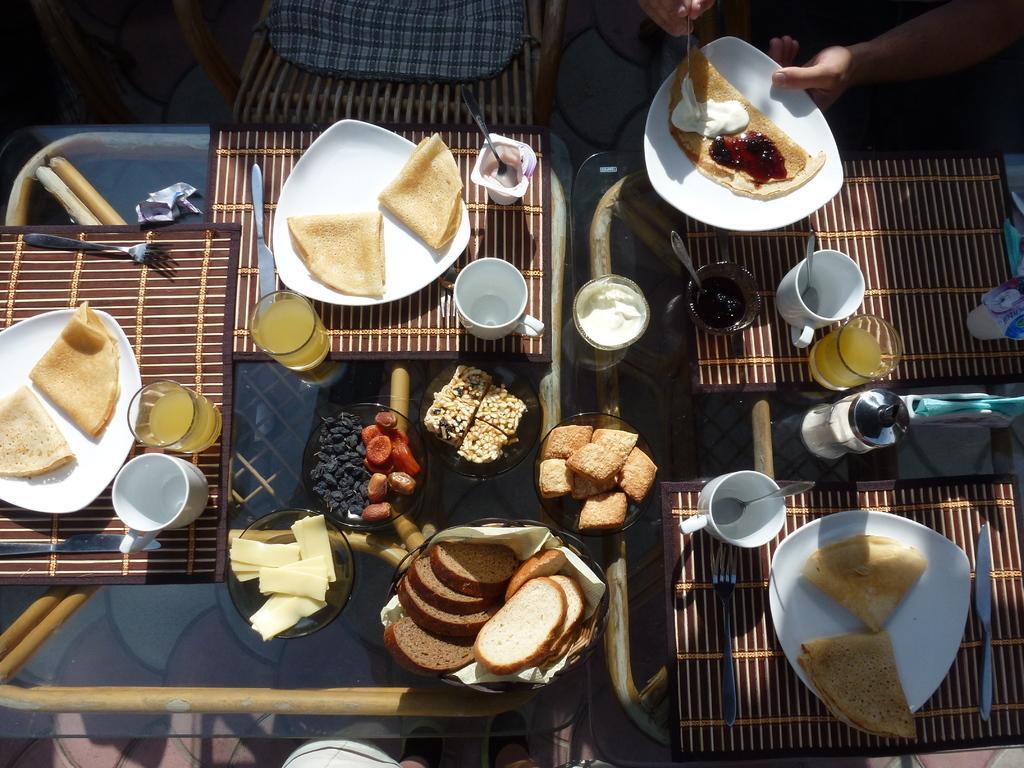Could you give a brief overview of what you see in this image? This image consists of food which is in the center on the table. There are glasses, cups on the table. At the top right there is a hand of the person which is visible and holding a plate and a spoon, and there is an empty chair. 